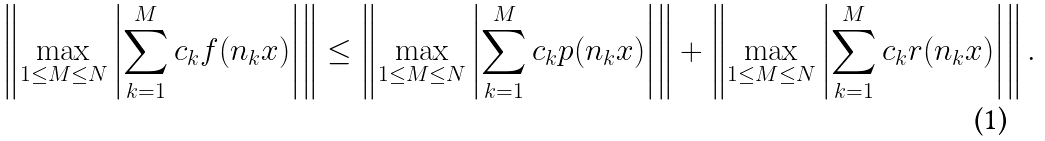<formula> <loc_0><loc_0><loc_500><loc_500>\left \| \max _ { 1 \leq M \leq N } \left | \sum _ { k = 1 } ^ { M } c _ { k } f ( n _ { k } x ) \right | \right \| \leq \left \| \max _ { 1 \leq M \leq N } \left | \sum _ { k = 1 } ^ { M } c _ { k } p ( n _ { k } x ) \right | \right \| + \left \| \max _ { 1 \leq M \leq N } \left | \sum _ { k = 1 } ^ { M } c _ { k } r ( n _ { k } x ) \right | \right \| .</formula> 